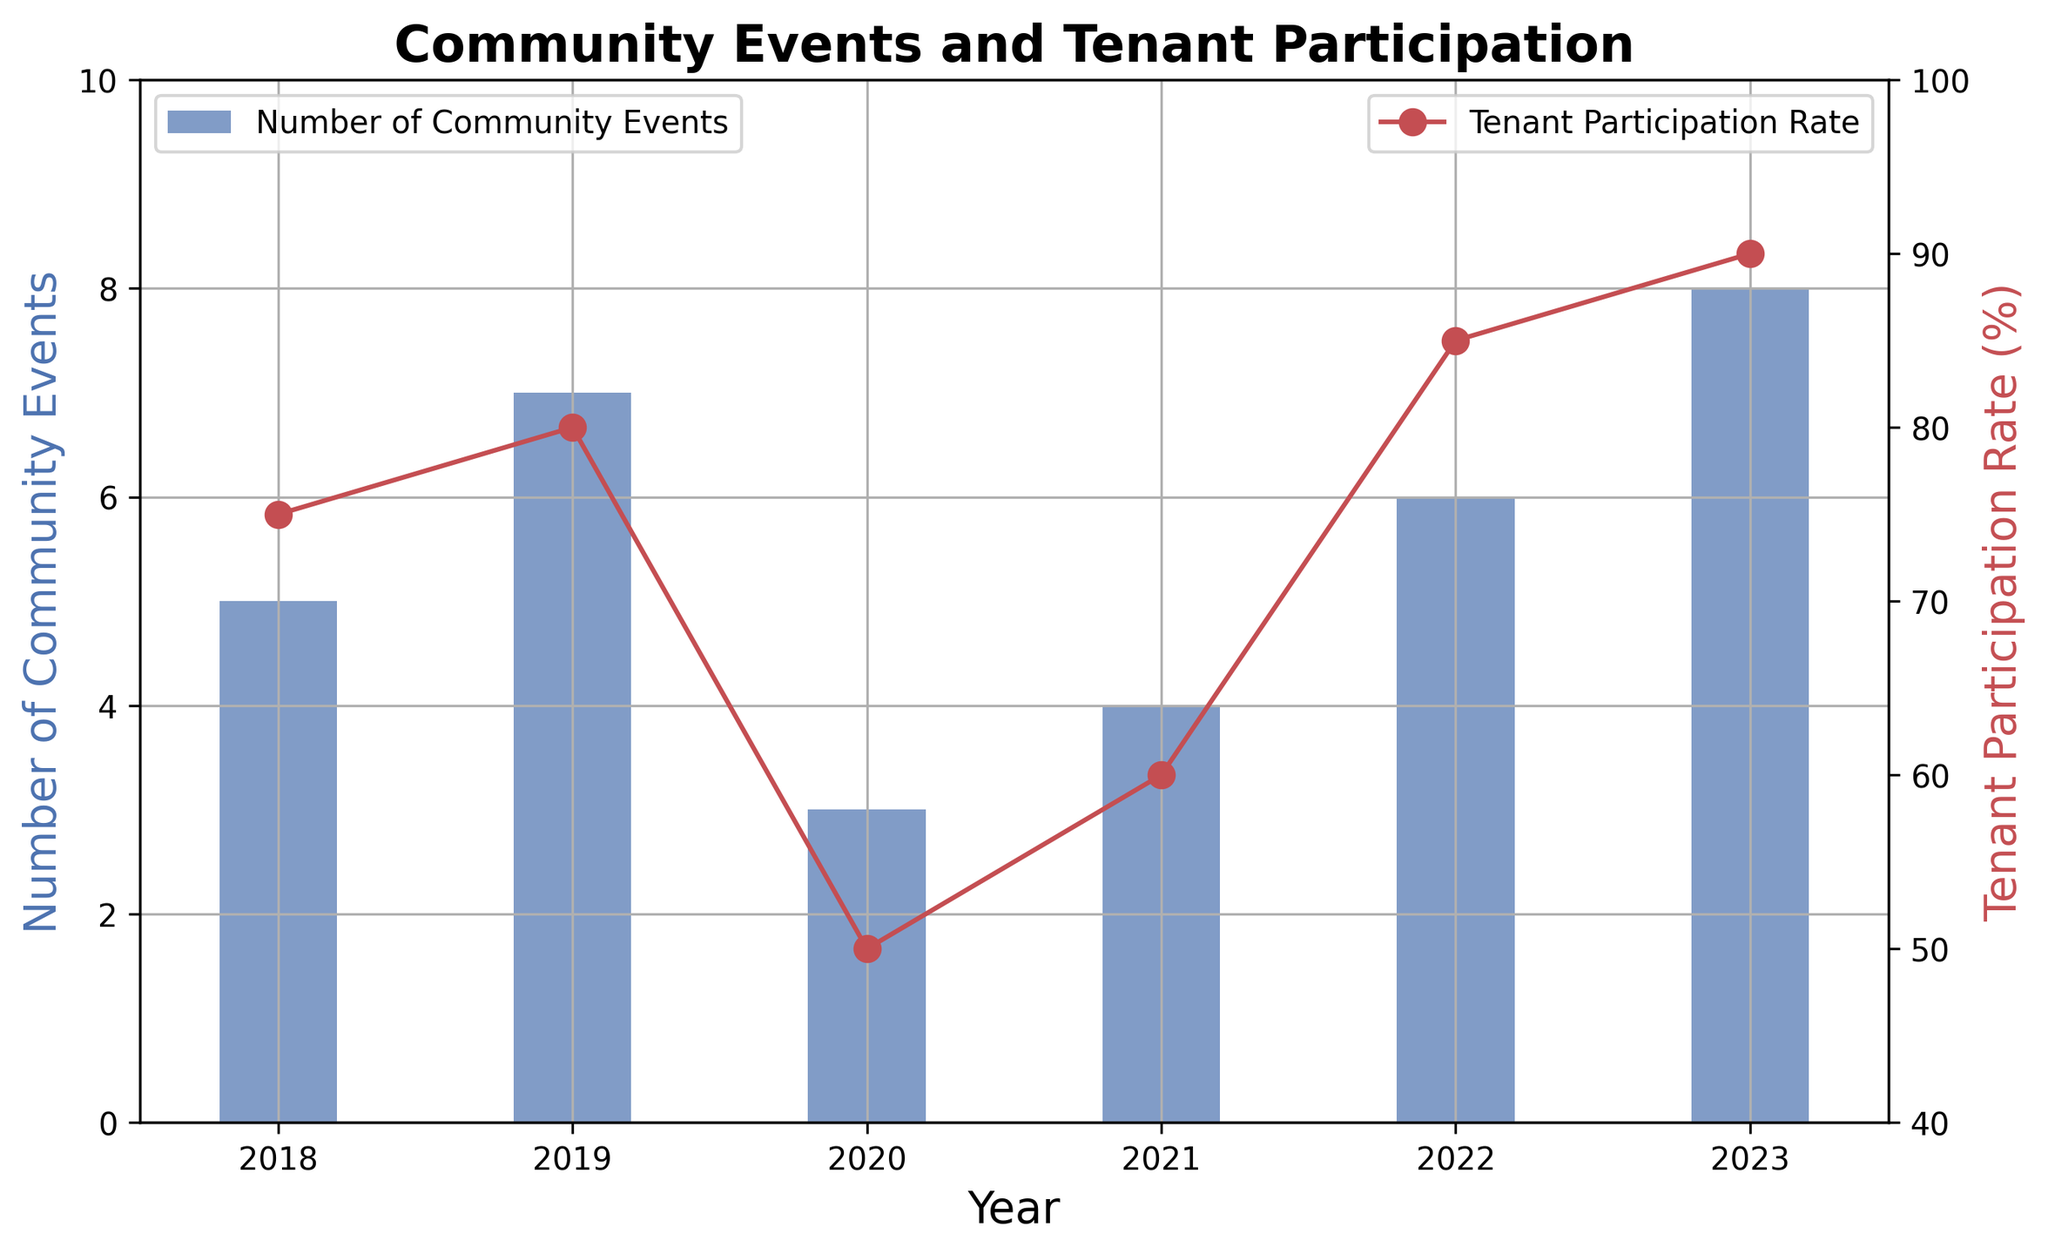How many community events were held in the year with the highest tenant participation rate? The highest tenant participation rate is 90%, which occurred in 2023. According to the bar chart, 8 community events were held in 2023.
Answer: 8 Which year saw the biggest drop in tenant participation rate compared to the previous year? By examining the red line, the largest drop in tenant participation rate happens between 2019 (80%) and 2020 (50%). The drop is 80% - 50% = 30%.
Answer: 2020 What is the average number of community events held over the years? Summing the number of community events from 2018 to 2023, we get 5 + 7 + 3 + 4 + 6 + 8 = 33. Dividing by the number of years (6), the average is 33/6.
Answer: 5.5 In which year was the number of community events less than twice the tenant participation rate (converted to whole numbers)? Converting tenant participation rates to whole numbers and multiplying by 2: 2018: 75*2=150, 2019: 80*2=160, 2020: 50*2=100, 2021: 60*2=120, 2022: 85*2=170, 2023: 90*2=180. Comparing these to community events, all years have fewer community events than twice the tenant participation rate. However, if we read the question as "less than or equal to": 2020: 3 community events < 100, 2021: 4 < 120. All years fit the question.
Answer: 2018, 2019, 2020, 2021, 2022, 2023 Which year had a higher tenant participation rate: 2018 or 2022? By comparing the red line values directly, 2018 has a participation rate of 75% while 2022 has a participation rate of 85%. Clearly, 2022 is higher.
Answer: 2022 What is the percentage increase in the number of community events from 2020 to 2023? In 2020, there were 3 events, and in 2023, there were 8 events. The increase is 8 - 3 = 5 events. The percentage increase is (5/3) * 100%.
Answer: 166.67% If you sum the tenant participation rates of 2018 and 2021, what do you get? Adding the tenant participation rates for 2018 (75%) and 2021 (60%) results in 75 + 60 = 135%.
Answer: 135% What was the trend in tenant participation rate from 2019 to 2023? Did it generally increase, decrease, or fluctuate? Examining the red line from 2019 (80%), it decreases in 2020 (50%), then increases gradually to 2021 (60%), 2022 (85%), and peaks in 2023 (90%). The general trend shows an increase after an initial decrease.
Answer: Increase 